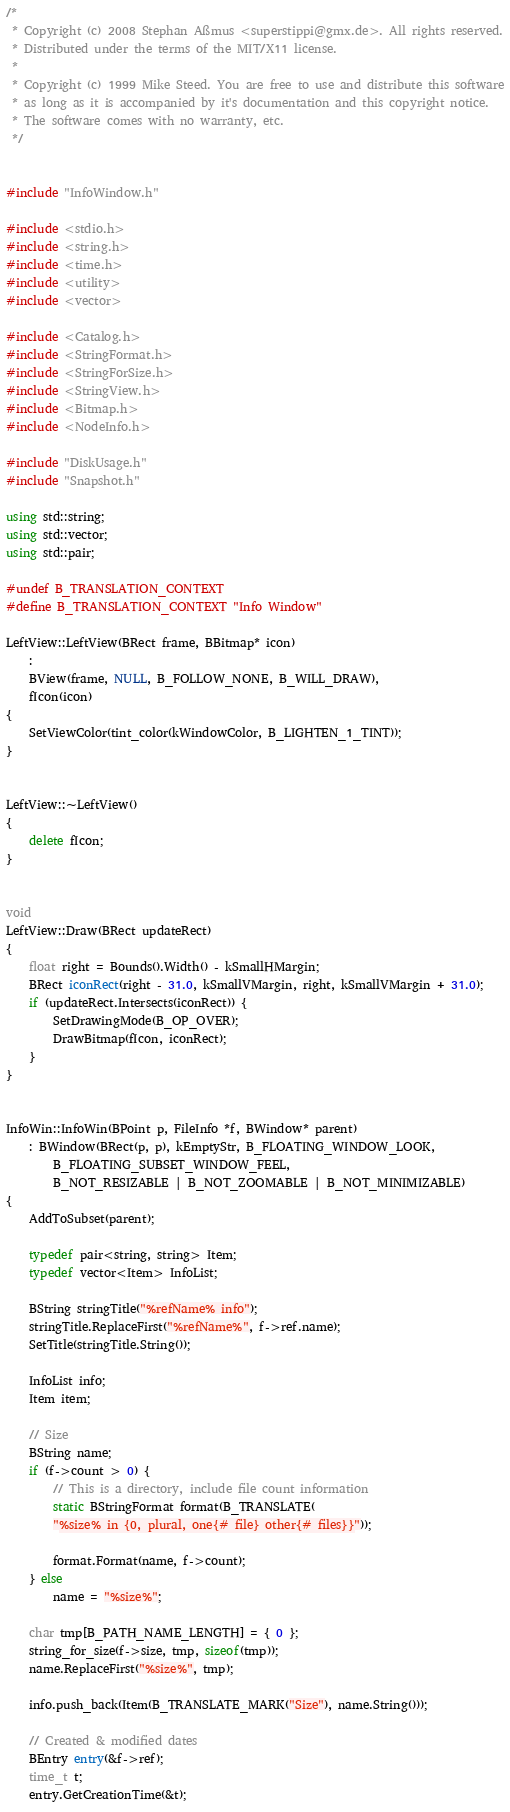<code> <loc_0><loc_0><loc_500><loc_500><_C++_>/*
 * Copyright (c) 2008 Stephan Aßmus <superstippi@gmx.de>. All rights reserved.
 * Distributed under the terms of the MIT/X11 license.
 *
 * Copyright (c) 1999 Mike Steed. You are free to use and distribute this software
 * as long as it is accompanied by it's documentation and this copyright notice.
 * The software comes with no warranty, etc.
 */


#include "InfoWindow.h"

#include <stdio.h>
#include <string.h>
#include <time.h>
#include <utility>
#include <vector>

#include <Catalog.h>
#include <StringFormat.h>
#include <StringForSize.h>
#include <StringView.h>
#include <Bitmap.h>
#include <NodeInfo.h>

#include "DiskUsage.h"
#include "Snapshot.h"

using std::string;
using std::vector;
using std::pair;

#undef B_TRANSLATION_CONTEXT
#define B_TRANSLATION_CONTEXT "Info Window"

LeftView::LeftView(BRect frame, BBitmap* icon)
	:
	BView(frame, NULL, B_FOLLOW_NONE, B_WILL_DRAW),
	fIcon(icon)
{
	SetViewColor(tint_color(kWindowColor, B_LIGHTEN_1_TINT));
}


LeftView::~LeftView()
{
	delete fIcon;
}


void
LeftView::Draw(BRect updateRect)
{
	float right = Bounds().Width() - kSmallHMargin;
	BRect iconRect(right - 31.0, kSmallVMargin, right, kSmallVMargin + 31.0);
	if (updateRect.Intersects(iconRect)) {
		SetDrawingMode(B_OP_OVER);
		DrawBitmap(fIcon, iconRect);
	}
}


InfoWin::InfoWin(BPoint p, FileInfo *f, BWindow* parent)
	: BWindow(BRect(p, p), kEmptyStr, B_FLOATING_WINDOW_LOOK,
		B_FLOATING_SUBSET_WINDOW_FEEL,
		B_NOT_RESIZABLE | B_NOT_ZOOMABLE | B_NOT_MINIMIZABLE)
{
	AddToSubset(parent);

	typedef pair<string, string> Item;
	typedef vector<Item> InfoList;

	BString stringTitle("%refName% info");
	stringTitle.ReplaceFirst("%refName%", f->ref.name);
	SetTitle(stringTitle.String());

	InfoList info;
	Item item;

	// Size
	BString name;
	if (f->count > 0) {
		// This is a directory, include file count information
		static BStringFormat format(B_TRANSLATE(
		"%size% in {0, plural, one{# file} other{# files}}"));

		format.Format(name, f->count);
	} else
		name = "%size%";

	char tmp[B_PATH_NAME_LENGTH] = { 0 };
	string_for_size(f->size, tmp, sizeof(tmp));
	name.ReplaceFirst("%size%", tmp);

	info.push_back(Item(B_TRANSLATE_MARK("Size"), name.String()));

	// Created & modified dates
	BEntry entry(&f->ref);
	time_t t;
	entry.GetCreationTime(&t);</code> 